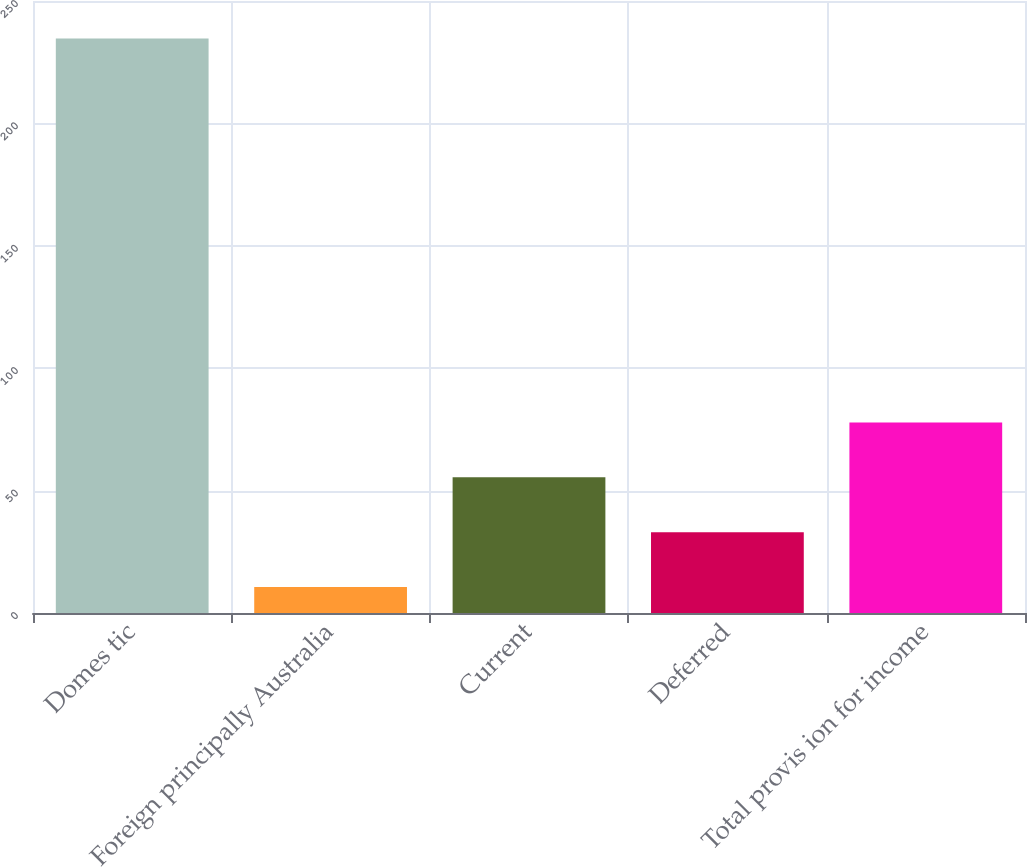<chart> <loc_0><loc_0><loc_500><loc_500><bar_chart><fcel>Domes tic<fcel>Foreign principally Australia<fcel>Current<fcel>Deferred<fcel>Total provis ion for income<nl><fcel>234.7<fcel>10.6<fcel>55.42<fcel>33.01<fcel>77.83<nl></chart> 